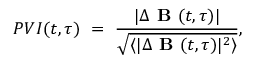Convert formula to latex. <formula><loc_0><loc_0><loc_500><loc_500>P V I ( t , \tau ) \ = \ \frac { | \Delta B ( t , \tau ) | } { \sqrt { \langle | \Delta B ( t , \tau ) | ^ { 2 } \rangle } } ,</formula> 